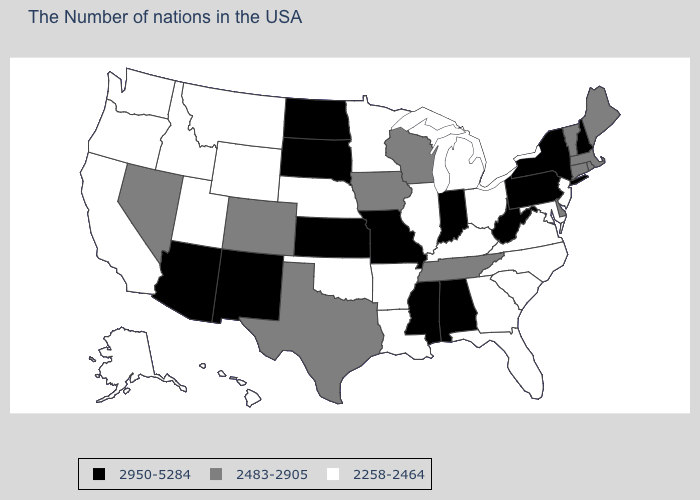What is the value of Indiana?
Answer briefly. 2950-5284. What is the highest value in states that border Kentucky?
Give a very brief answer. 2950-5284. Is the legend a continuous bar?
Give a very brief answer. No. What is the value of North Dakota?
Write a very short answer. 2950-5284. Name the states that have a value in the range 2483-2905?
Be succinct. Maine, Massachusetts, Rhode Island, Vermont, Connecticut, Delaware, Tennessee, Wisconsin, Iowa, Texas, Colorado, Nevada. Name the states that have a value in the range 2483-2905?
Give a very brief answer. Maine, Massachusetts, Rhode Island, Vermont, Connecticut, Delaware, Tennessee, Wisconsin, Iowa, Texas, Colorado, Nevada. Does Arkansas have the highest value in the USA?
Quick response, please. No. What is the value of Nevada?
Concise answer only. 2483-2905. What is the value of Connecticut?
Write a very short answer. 2483-2905. Among the states that border Virginia , which have the highest value?
Concise answer only. West Virginia. What is the value of West Virginia?
Quick response, please. 2950-5284. How many symbols are there in the legend?
Be succinct. 3. Does the map have missing data?
Short answer required. No. Which states hav the highest value in the MidWest?
Keep it brief. Indiana, Missouri, Kansas, South Dakota, North Dakota. 